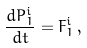Convert formula to latex. <formula><loc_0><loc_0><loc_500><loc_500>\frac { d P _ { 1 } ^ { i } } { d t } = F _ { 1 } ^ { i } \, ,</formula> 